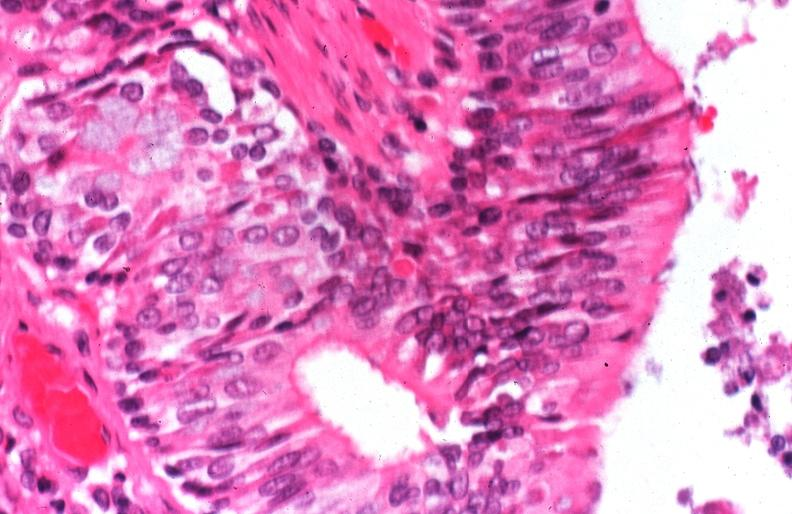s respiratory present?
Answer the question using a single word or phrase. Yes 